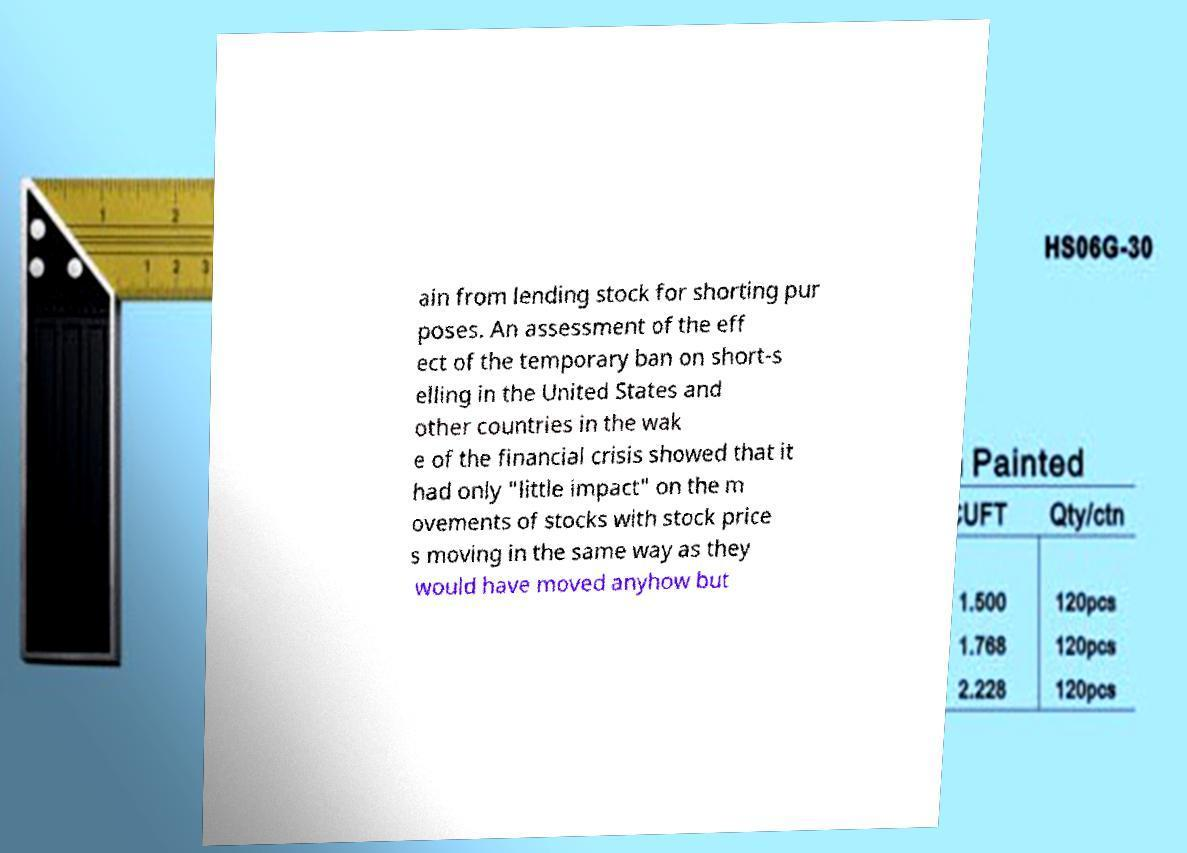Can you read and provide the text displayed in the image?This photo seems to have some interesting text. Can you extract and type it out for me? ain from lending stock for shorting pur poses. An assessment of the eff ect of the temporary ban on short-s elling in the United States and other countries in the wak e of the financial crisis showed that it had only "little impact" on the m ovements of stocks with stock price s moving in the same way as they would have moved anyhow but 